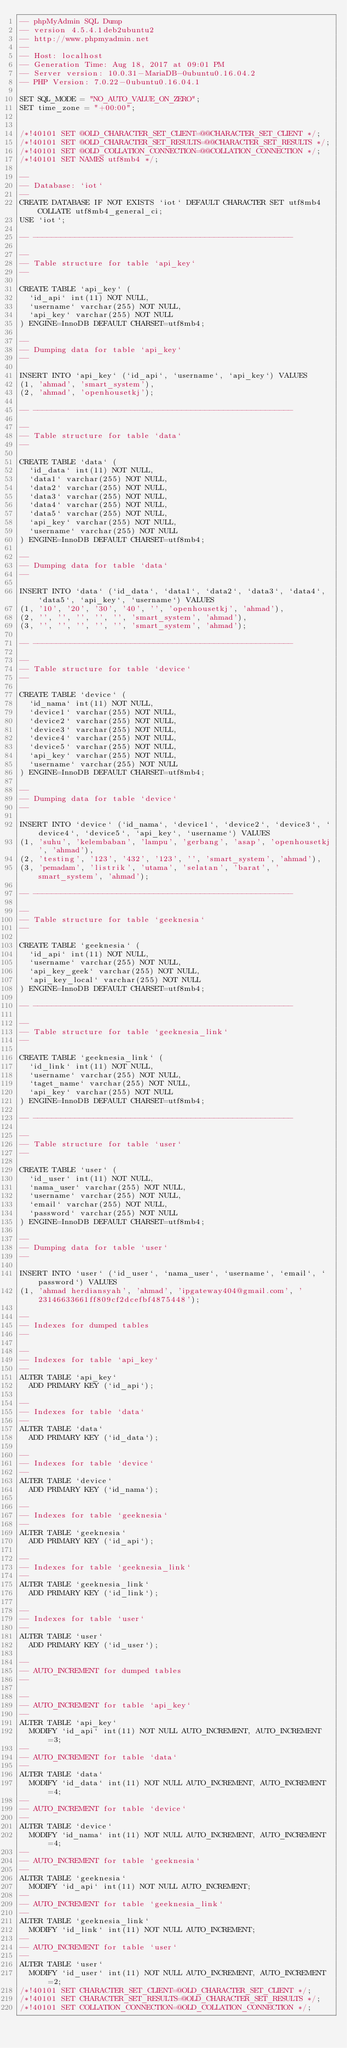<code> <loc_0><loc_0><loc_500><loc_500><_SQL_>-- phpMyAdmin SQL Dump
-- version 4.5.4.1deb2ubuntu2
-- http://www.phpmyadmin.net
--
-- Host: localhost
-- Generation Time: Aug 18, 2017 at 09:01 PM
-- Server version: 10.0.31-MariaDB-0ubuntu0.16.04.2
-- PHP Version: 7.0.22-0ubuntu0.16.04.1

SET SQL_MODE = "NO_AUTO_VALUE_ON_ZERO";
SET time_zone = "+00:00";


/*!40101 SET @OLD_CHARACTER_SET_CLIENT=@@CHARACTER_SET_CLIENT */;
/*!40101 SET @OLD_CHARACTER_SET_RESULTS=@@CHARACTER_SET_RESULTS */;
/*!40101 SET @OLD_COLLATION_CONNECTION=@@COLLATION_CONNECTION */;
/*!40101 SET NAMES utf8mb4 */;

--
-- Database: `iot`
--
CREATE DATABASE IF NOT EXISTS `iot` DEFAULT CHARACTER SET utf8mb4 COLLATE utf8mb4_general_ci;
USE `iot`;

-- --------------------------------------------------------

--
-- Table structure for table `api_key`
--

CREATE TABLE `api_key` (
  `id_api` int(11) NOT NULL,
  `username` varchar(255) NOT NULL,
  `api_key` varchar(255) NOT NULL
) ENGINE=InnoDB DEFAULT CHARSET=utf8mb4;

--
-- Dumping data for table `api_key`
--

INSERT INTO `api_key` (`id_api`, `username`, `api_key`) VALUES
(1, 'ahmad', 'smart_system'),
(2, 'ahmad', 'openhousetkj');

-- --------------------------------------------------------

--
-- Table structure for table `data`
--

CREATE TABLE `data` (
  `id_data` int(11) NOT NULL,
  `data1` varchar(255) NOT NULL,
  `data2` varchar(255) NOT NULL,
  `data3` varchar(255) NOT NULL,
  `data4` varchar(255) NOT NULL,
  `data5` varchar(255) NOT NULL,
  `api_key` varchar(255) NOT NULL,
  `username` varchar(255) NOT NULL
) ENGINE=InnoDB DEFAULT CHARSET=utf8mb4;

--
-- Dumping data for table `data`
--

INSERT INTO `data` (`id_data`, `data1`, `data2`, `data3`, `data4`, `data5`, `api_key`, `username`) VALUES
(1, '10', '20', '30', '40', '', 'openhousetkj', 'ahmad'),
(2, '', '', '', '', '', 'smart_system', 'ahmad'),
(3, '', '', '', '', '', 'smart_system', 'ahmad');

-- --------------------------------------------------------

--
-- Table structure for table `device`
--

CREATE TABLE `device` (
  `id_nama` int(11) NOT NULL,
  `device1` varchar(255) NOT NULL,
  `device2` varchar(255) NOT NULL,
  `device3` varchar(255) NOT NULL,
  `device4` varchar(255) NOT NULL,
  `device5` varchar(255) NOT NULL,
  `api_key` varchar(255) NOT NULL,
  `username` varchar(255) NOT NULL
) ENGINE=InnoDB DEFAULT CHARSET=utf8mb4;

--
-- Dumping data for table `device`
--

INSERT INTO `device` (`id_nama`, `device1`, `device2`, `device3`, `device4`, `device5`, `api_key`, `username`) VALUES
(1, 'suhu', 'kelembaban', 'lampu', 'gerbang', 'asap', 'openhousetkj', 'ahmad'),
(2, 'testing', '123', '432', '123', '', 'smart_system', 'ahmad'),
(3, 'pemadam', 'listrik', 'utama', 'selatan', 'barat', 'smart_system', 'ahmad');

-- --------------------------------------------------------

--
-- Table structure for table `geeknesia`
--

CREATE TABLE `geeknesia` (
  `id_api` int(11) NOT NULL,
  `username` varchar(255) NOT NULL,
  `api_key_geek` varchar(255) NOT NULL,
  `api_key_local` varchar(255) NOT NULL
) ENGINE=InnoDB DEFAULT CHARSET=utf8mb4;

-- --------------------------------------------------------

--
-- Table structure for table `geeknesia_link`
--

CREATE TABLE `geeknesia_link` (
  `id_link` int(11) NOT NULL,
  `username` varchar(255) NOT NULL,
  `taget_name` varchar(255) NOT NULL,
  `api_key` varchar(255) NOT NULL
) ENGINE=InnoDB DEFAULT CHARSET=utf8mb4;

-- --------------------------------------------------------

--
-- Table structure for table `user`
--

CREATE TABLE `user` (
  `id_user` int(11) NOT NULL,
  `nama_user` varchar(255) NOT NULL,
  `username` varchar(255) NOT NULL,
  `email` varchar(255) NOT NULL,
  `password` varchar(255) NOT NULL
) ENGINE=InnoDB DEFAULT CHARSET=utf8mb4;

--
-- Dumping data for table `user`
--

INSERT INTO `user` (`id_user`, `nama_user`, `username`, `email`, `password`) VALUES
(1, 'ahmad herdiansyah', 'ahmad', 'ipgateway404@gmail.com', '23146633661ff809cf2dcefbf4875448');

--
-- Indexes for dumped tables
--

--
-- Indexes for table `api_key`
--
ALTER TABLE `api_key`
  ADD PRIMARY KEY (`id_api`);

--
-- Indexes for table `data`
--
ALTER TABLE `data`
  ADD PRIMARY KEY (`id_data`);

--
-- Indexes for table `device`
--
ALTER TABLE `device`
  ADD PRIMARY KEY (`id_nama`);

--
-- Indexes for table `geeknesia`
--
ALTER TABLE `geeknesia`
  ADD PRIMARY KEY (`id_api`);

--
-- Indexes for table `geeknesia_link`
--
ALTER TABLE `geeknesia_link`
  ADD PRIMARY KEY (`id_link`);

--
-- Indexes for table `user`
--
ALTER TABLE `user`
  ADD PRIMARY KEY (`id_user`);

--
-- AUTO_INCREMENT for dumped tables
--

--
-- AUTO_INCREMENT for table `api_key`
--
ALTER TABLE `api_key`
  MODIFY `id_api` int(11) NOT NULL AUTO_INCREMENT, AUTO_INCREMENT=3;
--
-- AUTO_INCREMENT for table `data`
--
ALTER TABLE `data`
  MODIFY `id_data` int(11) NOT NULL AUTO_INCREMENT, AUTO_INCREMENT=4;
--
-- AUTO_INCREMENT for table `device`
--
ALTER TABLE `device`
  MODIFY `id_nama` int(11) NOT NULL AUTO_INCREMENT, AUTO_INCREMENT=4;
--
-- AUTO_INCREMENT for table `geeknesia`
--
ALTER TABLE `geeknesia`
  MODIFY `id_api` int(11) NOT NULL AUTO_INCREMENT;
--
-- AUTO_INCREMENT for table `geeknesia_link`
--
ALTER TABLE `geeknesia_link`
  MODIFY `id_link` int(11) NOT NULL AUTO_INCREMENT;
--
-- AUTO_INCREMENT for table `user`
--
ALTER TABLE `user`
  MODIFY `id_user` int(11) NOT NULL AUTO_INCREMENT, AUTO_INCREMENT=2;
/*!40101 SET CHARACTER_SET_CLIENT=@OLD_CHARACTER_SET_CLIENT */;
/*!40101 SET CHARACTER_SET_RESULTS=@OLD_CHARACTER_SET_RESULTS */;
/*!40101 SET COLLATION_CONNECTION=@OLD_COLLATION_CONNECTION */;
</code> 